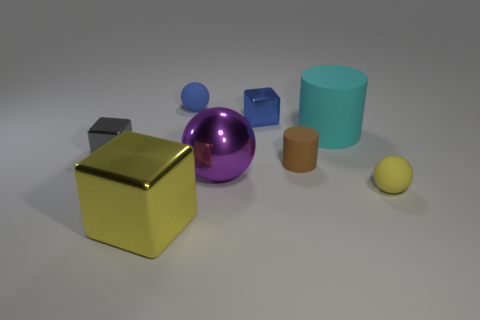There is a tiny shiny object that is behind the large rubber cylinder; is it the same shape as the tiny gray thing?
Provide a short and direct response. Yes. How many things are blue matte spheres or cyan cylinders?
Your response must be concise. 2. There is a ball that is in front of the blue metallic block and on the left side of the small brown cylinder; what is its material?
Make the answer very short. Metal. Do the yellow matte sphere and the metallic sphere have the same size?
Ensure brevity in your answer.  No. There is a yellow thing that is on the left side of the matte object behind the big matte thing; what is its size?
Your answer should be compact. Large. How many small things are behind the big purple ball and in front of the blue cube?
Make the answer very short. 2. Is there a yellow cube right of the big purple metal sphere to the right of the large shiny object that is in front of the big purple thing?
Provide a succinct answer. No. What shape is the yellow matte thing that is the same size as the blue shiny cube?
Your answer should be compact. Sphere. Is there a tiny object of the same color as the big shiny cube?
Keep it short and to the point. Yes. Is the cyan thing the same shape as the tiny brown object?
Provide a succinct answer. Yes. 